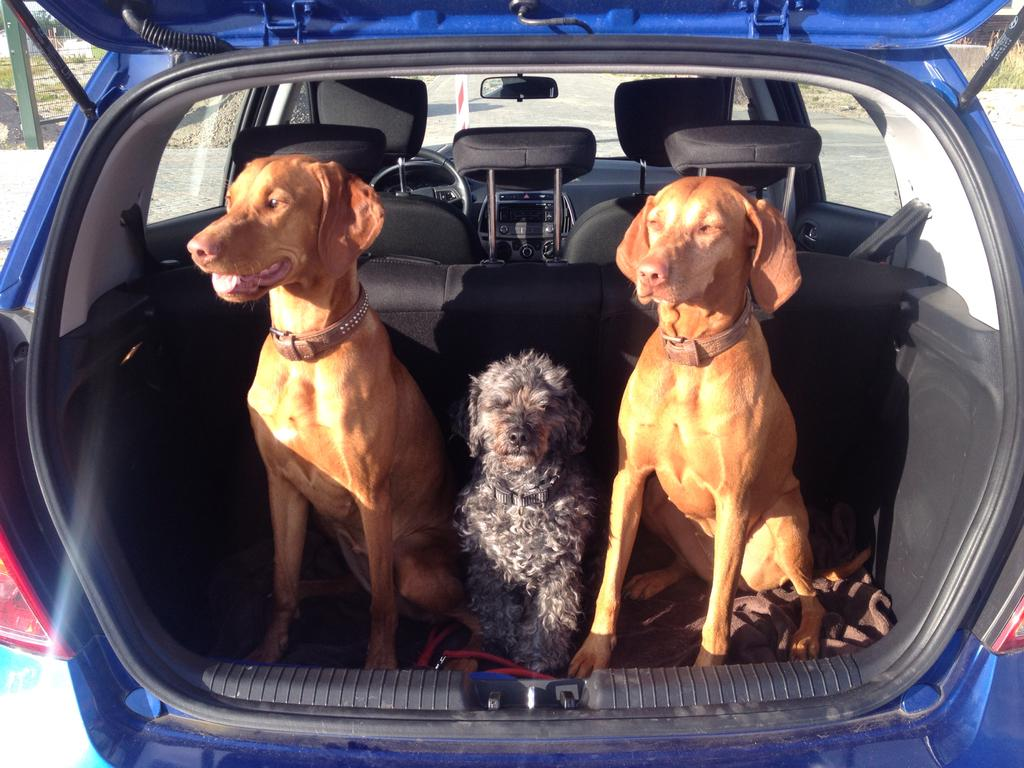How many dogs are in the image? There are three dogs in the image. Where are the dogs located? The dogs are in a car. What can be seen in the background of the image? There is a pole and trees visible in the background of the image. What type of locket is the person wearing in the image? There is no person present in the image, so there is no locket to be seen. 